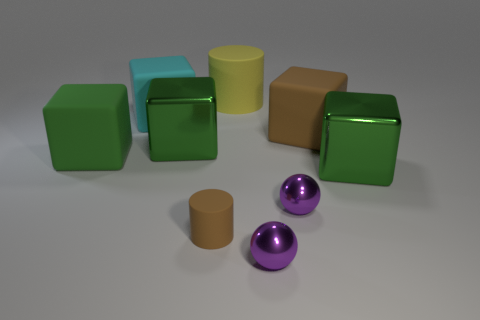Is there anything else that has the same color as the tiny rubber thing?
Make the answer very short. Yes. There is a cylinder in front of the big cyan cube; is it the same color as the large metal block on the left side of the big yellow object?
Your response must be concise. No. Are any tiny purple spheres visible?
Provide a short and direct response. Yes. Is there a big cylinder that has the same material as the big cyan block?
Offer a terse response. Yes. The large cylinder has what color?
Your response must be concise. Yellow. There is a large object that is the same color as the small rubber cylinder; what shape is it?
Make the answer very short. Cube. There is a rubber cylinder that is the same size as the green matte block; what is its color?
Keep it short and to the point. Yellow. What number of rubber objects are cyan cubes or purple cubes?
Keep it short and to the point. 1. What number of large matte things are on the right side of the cyan rubber object and in front of the large yellow cylinder?
Your answer should be very brief. 1. Is there anything else that has the same shape as the small brown rubber thing?
Offer a terse response. Yes. 